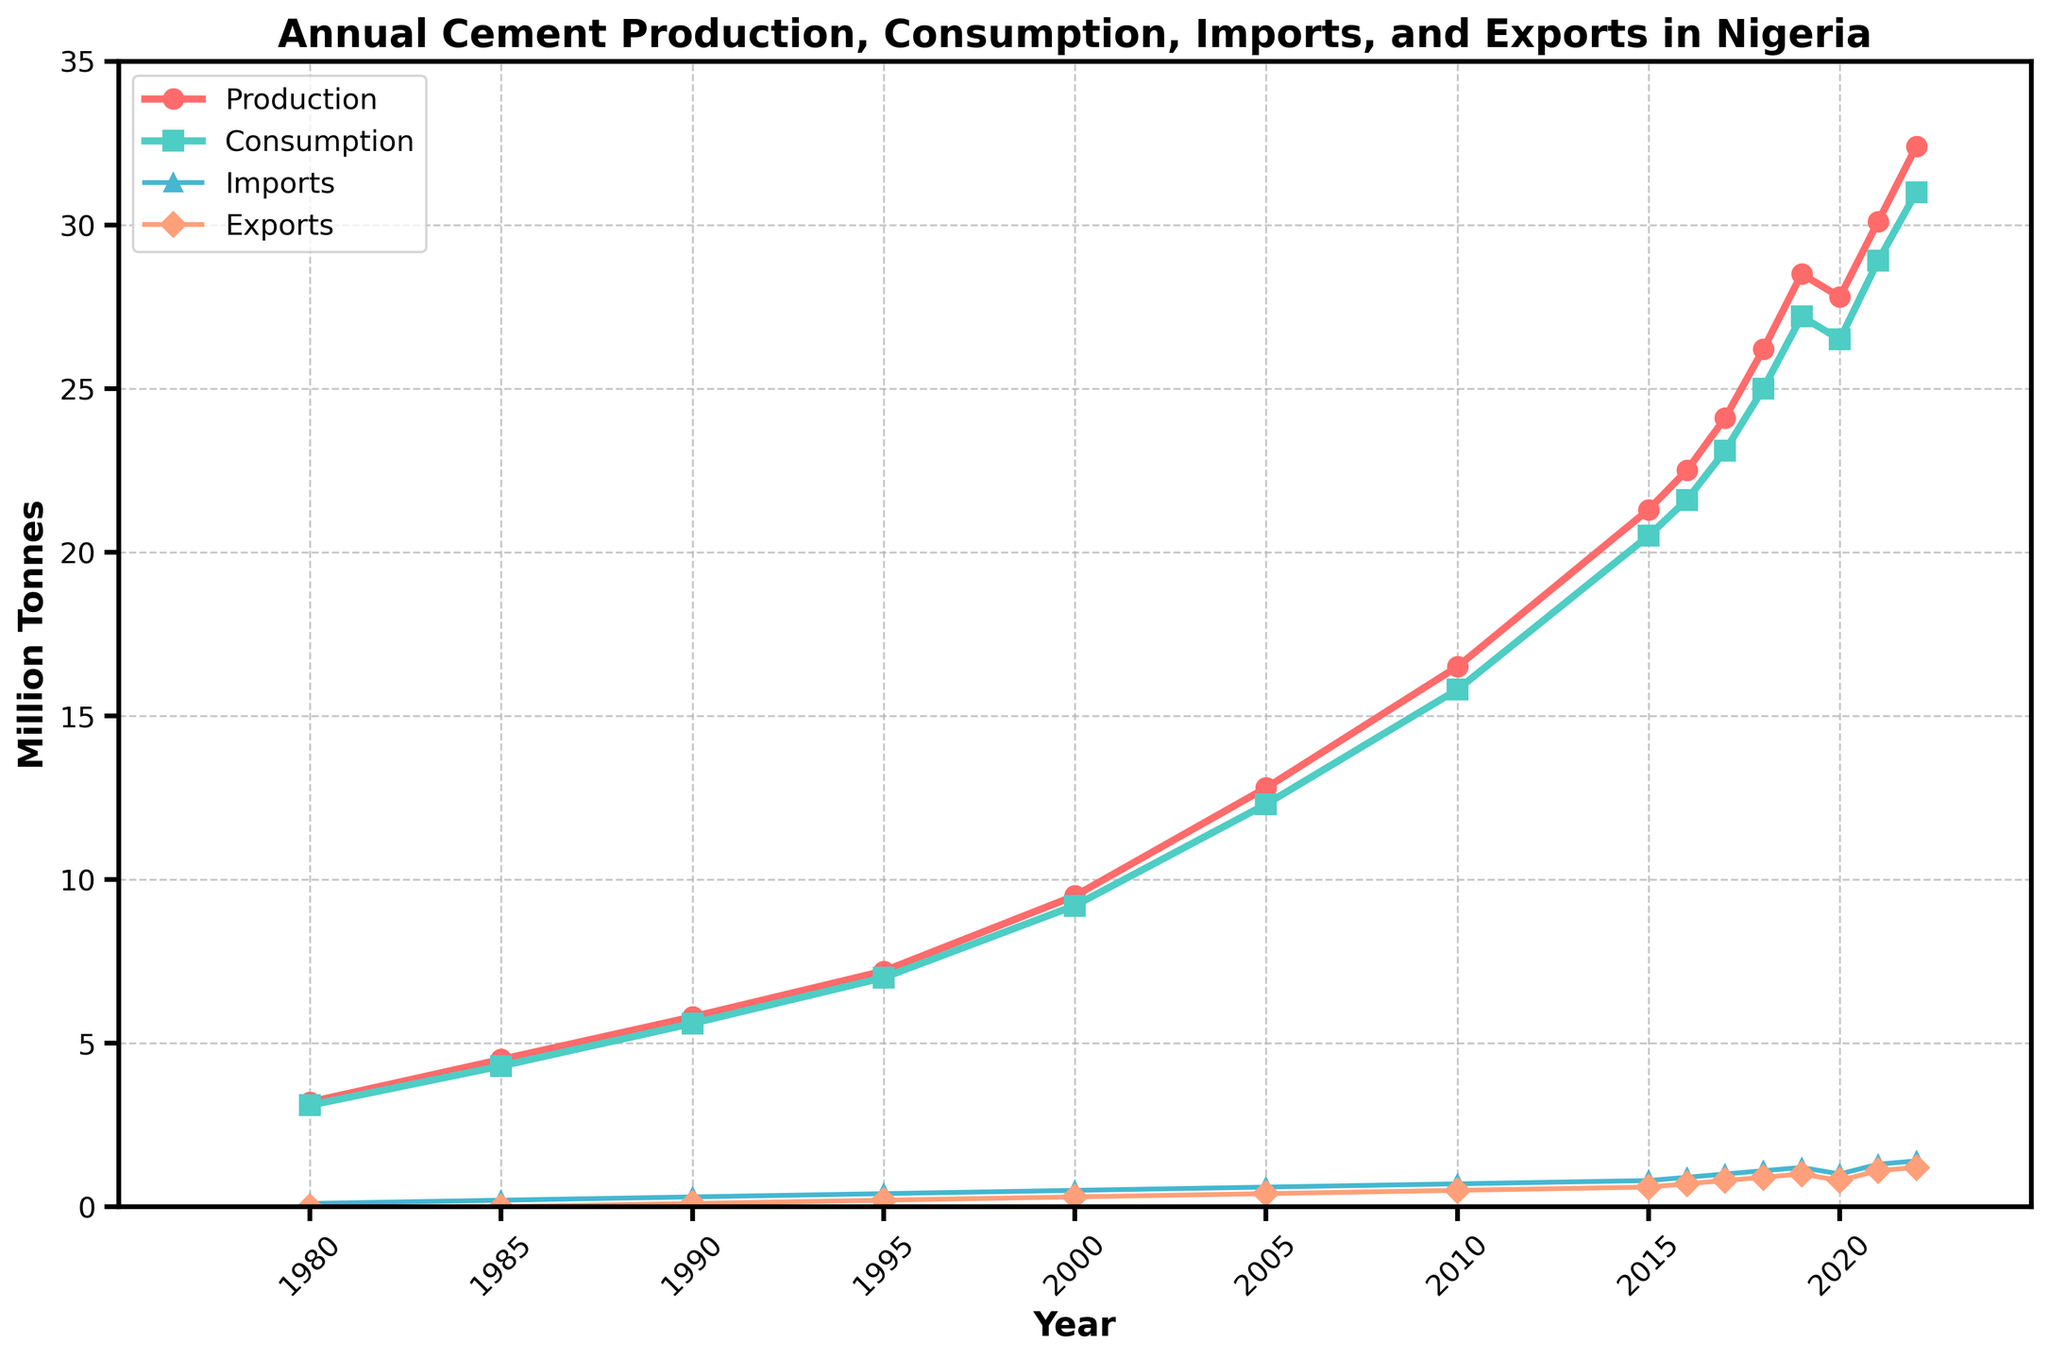What year saw the highest cement production? The peak of the red line (production) marks the highest production year visually.
Answer: 2022 By how much did consumption increase from 1980 to 2022? Look at the green line (consumption) values in 1980 and 2022 to compute the difference: 31.0 in 2022 minus 3.1 in 1980.
Answer: 27.9 million tonnes How does the import volume in 2010 compare to 2020? Check the height of the blue triangles (imports) at 2010 and 2020; in 2010 it's 0.7, and in 2020 it's 1.0.
Answer: Imports increased by 0.3 million tonnes from 2010 to 2020 What is the trend comparison between production and consumption from 2000 to 2022? Visually, the red and green lines both ascend; production consistently stays above consumption except for a short dip in 2020.
Answer: Both increased, production consistently outpaces consumption with a dip in 2020 Which year had the smallest gap between production and consumption? Visually identify the year where the red and green lines (production and consumption) are closest together. In 1980, the production is 3.2 and consumption is 3.1.
Answer: 1980 How did exports change from 1990 to 2005? The orange diamond markers for exports show an increase from 0.1 in 1990 to 0.4 in 2005.
Answer: Increased by 0.3 million tonnes In 2019, what is the sum of production, consumption, imports, and exports? Add the visual readings for production (28.5), consumption (27.2), imports (1.2), and exports (1.0).
Answer: 57.9 million tonnes Did any year's consumption exceed production? Compare the heights of the red (production) and green (consumption) lines for any year; none of the green segments are higher than their corresponding red segments.
Answer: No 